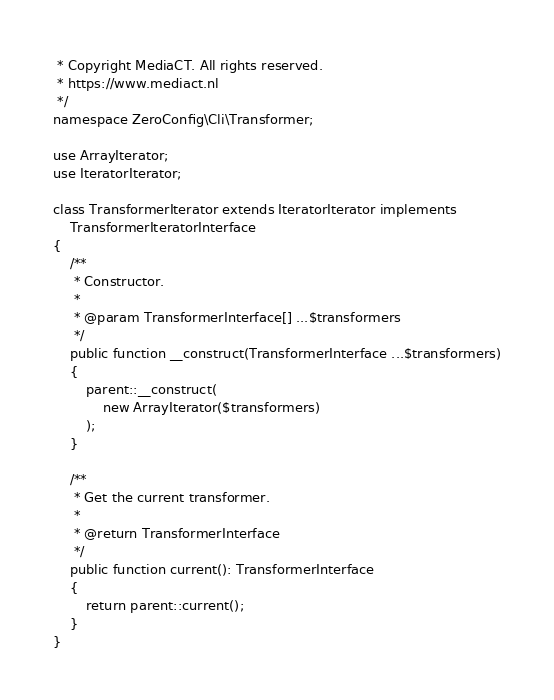Convert code to text. <code><loc_0><loc_0><loc_500><loc_500><_PHP_> * Copyright MediaCT. All rights reserved.
 * https://www.mediact.nl
 */
namespace ZeroConfig\Cli\Transformer;

use ArrayIterator;
use IteratorIterator;

class TransformerIterator extends IteratorIterator implements
    TransformerIteratorInterface
{
    /**
     * Constructor.
     *
     * @param TransformerInterface[] ...$transformers
     */
    public function __construct(TransformerInterface ...$transformers)
    {
        parent::__construct(
            new ArrayIterator($transformers)
        );
    }

    /**
     * Get the current transformer.
     *
     * @return TransformerInterface
     */
    public function current(): TransformerInterface
    {
        return parent::current();
    }
}
</code> 